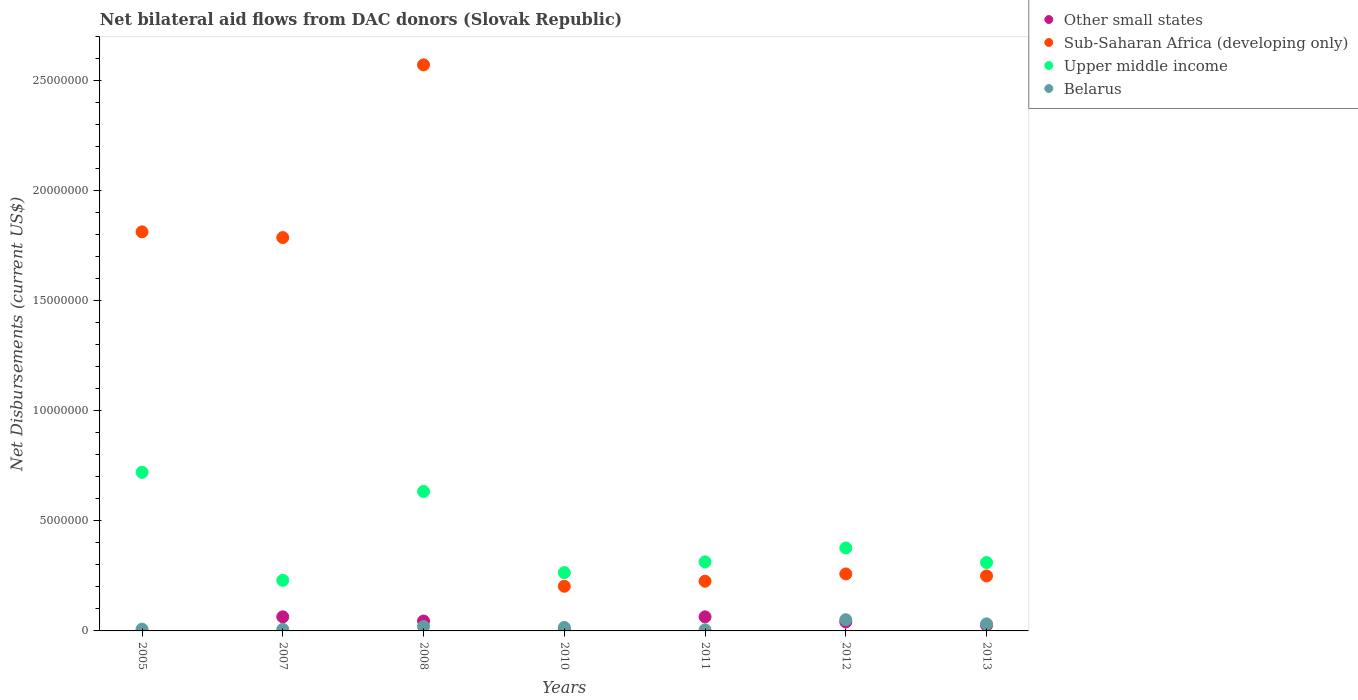What is the net bilateral aid flows in Upper middle income in 2011?
Keep it short and to the point. 3.14e+06. Across all years, what is the maximum net bilateral aid flows in Other small states?
Offer a terse response. 6.40e+05. In which year was the net bilateral aid flows in Upper middle income maximum?
Your answer should be very brief. 2005. What is the total net bilateral aid flows in Sub-Saharan Africa (developing only) in the graph?
Offer a terse response. 7.11e+07. What is the difference between the net bilateral aid flows in Upper middle income in 2011 and that in 2012?
Your answer should be compact. -6.30e+05. What is the difference between the net bilateral aid flows in Upper middle income in 2011 and the net bilateral aid flows in Belarus in 2007?
Keep it short and to the point. 3.07e+06. What is the average net bilateral aid flows in Upper middle income per year?
Provide a short and direct response. 4.07e+06. In the year 2012, what is the difference between the net bilateral aid flows in Sub-Saharan Africa (developing only) and net bilateral aid flows in Belarus?
Offer a terse response. 2.08e+06. In how many years, is the net bilateral aid flows in Belarus greater than 6000000 US$?
Your response must be concise. 0. What is the ratio of the net bilateral aid flows in Belarus in 2010 to that in 2013?
Your answer should be compact. 0.5. Is the net bilateral aid flows in Sub-Saharan Africa (developing only) in 2005 less than that in 2013?
Keep it short and to the point. No. What is the difference between the highest and the second highest net bilateral aid flows in Upper middle income?
Your response must be concise. 8.70e+05. What is the difference between the highest and the lowest net bilateral aid flows in Upper middle income?
Give a very brief answer. 4.91e+06. Is it the case that in every year, the sum of the net bilateral aid flows in Sub-Saharan Africa (developing only) and net bilateral aid flows in Upper middle income  is greater than the sum of net bilateral aid flows in Belarus and net bilateral aid flows in Other small states?
Provide a succinct answer. Yes. Is it the case that in every year, the sum of the net bilateral aid flows in Other small states and net bilateral aid flows in Sub-Saharan Africa (developing only)  is greater than the net bilateral aid flows in Belarus?
Your answer should be very brief. Yes. Does the net bilateral aid flows in Belarus monotonically increase over the years?
Keep it short and to the point. No. How many years are there in the graph?
Keep it short and to the point. 7. Are the values on the major ticks of Y-axis written in scientific E-notation?
Your answer should be very brief. No. Where does the legend appear in the graph?
Provide a short and direct response. Top right. How are the legend labels stacked?
Ensure brevity in your answer.  Vertical. What is the title of the graph?
Offer a terse response. Net bilateral aid flows from DAC donors (Slovak Republic). What is the label or title of the X-axis?
Your answer should be compact. Years. What is the label or title of the Y-axis?
Offer a very short reply. Net Disbursements (current US$). What is the Net Disbursements (current US$) in Sub-Saharan Africa (developing only) in 2005?
Give a very brief answer. 1.81e+07. What is the Net Disbursements (current US$) in Upper middle income in 2005?
Give a very brief answer. 7.21e+06. What is the Net Disbursements (current US$) in Belarus in 2005?
Provide a succinct answer. 8.00e+04. What is the Net Disbursements (current US$) in Other small states in 2007?
Offer a very short reply. 6.40e+05. What is the Net Disbursements (current US$) of Sub-Saharan Africa (developing only) in 2007?
Provide a succinct answer. 1.79e+07. What is the Net Disbursements (current US$) of Upper middle income in 2007?
Offer a terse response. 2.30e+06. What is the Net Disbursements (current US$) in Sub-Saharan Africa (developing only) in 2008?
Make the answer very short. 2.57e+07. What is the Net Disbursements (current US$) in Upper middle income in 2008?
Offer a terse response. 6.34e+06. What is the Net Disbursements (current US$) in Other small states in 2010?
Your response must be concise. 8.00e+04. What is the Net Disbursements (current US$) of Sub-Saharan Africa (developing only) in 2010?
Your answer should be very brief. 2.03e+06. What is the Net Disbursements (current US$) in Upper middle income in 2010?
Ensure brevity in your answer.  2.65e+06. What is the Net Disbursements (current US$) of Other small states in 2011?
Your response must be concise. 6.40e+05. What is the Net Disbursements (current US$) in Sub-Saharan Africa (developing only) in 2011?
Provide a succinct answer. 2.26e+06. What is the Net Disbursements (current US$) in Upper middle income in 2011?
Your answer should be compact. 3.14e+06. What is the Net Disbursements (current US$) of Other small states in 2012?
Ensure brevity in your answer.  4.10e+05. What is the Net Disbursements (current US$) in Sub-Saharan Africa (developing only) in 2012?
Keep it short and to the point. 2.59e+06. What is the Net Disbursements (current US$) of Upper middle income in 2012?
Ensure brevity in your answer.  3.77e+06. What is the Net Disbursements (current US$) of Belarus in 2012?
Give a very brief answer. 5.10e+05. What is the Net Disbursements (current US$) of Other small states in 2013?
Your answer should be compact. 2.60e+05. What is the Net Disbursements (current US$) of Sub-Saharan Africa (developing only) in 2013?
Keep it short and to the point. 2.50e+06. What is the Net Disbursements (current US$) in Upper middle income in 2013?
Ensure brevity in your answer.  3.11e+06. What is the Net Disbursements (current US$) of Belarus in 2013?
Provide a succinct answer. 3.20e+05. Across all years, what is the maximum Net Disbursements (current US$) in Other small states?
Your answer should be compact. 6.40e+05. Across all years, what is the maximum Net Disbursements (current US$) in Sub-Saharan Africa (developing only)?
Your response must be concise. 2.57e+07. Across all years, what is the maximum Net Disbursements (current US$) in Upper middle income?
Your response must be concise. 7.21e+06. Across all years, what is the maximum Net Disbursements (current US$) of Belarus?
Offer a very short reply. 5.10e+05. Across all years, what is the minimum Net Disbursements (current US$) of Sub-Saharan Africa (developing only)?
Keep it short and to the point. 2.03e+06. Across all years, what is the minimum Net Disbursements (current US$) of Upper middle income?
Offer a very short reply. 2.30e+06. What is the total Net Disbursements (current US$) of Other small states in the graph?
Your response must be concise. 2.49e+06. What is the total Net Disbursements (current US$) of Sub-Saharan Africa (developing only) in the graph?
Offer a very short reply. 7.11e+07. What is the total Net Disbursements (current US$) of Upper middle income in the graph?
Your answer should be very brief. 2.85e+07. What is the total Net Disbursements (current US$) of Belarus in the graph?
Your answer should be compact. 1.39e+06. What is the difference between the Net Disbursements (current US$) in Other small states in 2005 and that in 2007?
Offer a terse response. -6.30e+05. What is the difference between the Net Disbursements (current US$) of Upper middle income in 2005 and that in 2007?
Provide a succinct answer. 4.91e+06. What is the difference between the Net Disbursements (current US$) in Other small states in 2005 and that in 2008?
Offer a terse response. -4.40e+05. What is the difference between the Net Disbursements (current US$) in Sub-Saharan Africa (developing only) in 2005 and that in 2008?
Your answer should be very brief. -7.59e+06. What is the difference between the Net Disbursements (current US$) of Upper middle income in 2005 and that in 2008?
Your response must be concise. 8.70e+05. What is the difference between the Net Disbursements (current US$) of Belarus in 2005 and that in 2008?
Your answer should be very brief. -1.20e+05. What is the difference between the Net Disbursements (current US$) in Sub-Saharan Africa (developing only) in 2005 and that in 2010?
Provide a succinct answer. 1.61e+07. What is the difference between the Net Disbursements (current US$) of Upper middle income in 2005 and that in 2010?
Provide a short and direct response. 4.56e+06. What is the difference between the Net Disbursements (current US$) in Belarus in 2005 and that in 2010?
Your response must be concise. -8.00e+04. What is the difference between the Net Disbursements (current US$) of Other small states in 2005 and that in 2011?
Ensure brevity in your answer.  -6.30e+05. What is the difference between the Net Disbursements (current US$) of Sub-Saharan Africa (developing only) in 2005 and that in 2011?
Provide a short and direct response. 1.59e+07. What is the difference between the Net Disbursements (current US$) in Upper middle income in 2005 and that in 2011?
Your answer should be very brief. 4.07e+06. What is the difference between the Net Disbursements (current US$) of Other small states in 2005 and that in 2012?
Your answer should be very brief. -4.00e+05. What is the difference between the Net Disbursements (current US$) of Sub-Saharan Africa (developing only) in 2005 and that in 2012?
Give a very brief answer. 1.56e+07. What is the difference between the Net Disbursements (current US$) of Upper middle income in 2005 and that in 2012?
Provide a succinct answer. 3.44e+06. What is the difference between the Net Disbursements (current US$) of Belarus in 2005 and that in 2012?
Provide a succinct answer. -4.30e+05. What is the difference between the Net Disbursements (current US$) of Sub-Saharan Africa (developing only) in 2005 and that in 2013?
Your answer should be very brief. 1.56e+07. What is the difference between the Net Disbursements (current US$) in Upper middle income in 2005 and that in 2013?
Offer a very short reply. 4.10e+06. What is the difference between the Net Disbursements (current US$) in Sub-Saharan Africa (developing only) in 2007 and that in 2008?
Your answer should be compact. -7.85e+06. What is the difference between the Net Disbursements (current US$) in Upper middle income in 2007 and that in 2008?
Provide a succinct answer. -4.04e+06. What is the difference between the Net Disbursements (current US$) in Belarus in 2007 and that in 2008?
Give a very brief answer. -1.30e+05. What is the difference between the Net Disbursements (current US$) of Other small states in 2007 and that in 2010?
Your answer should be compact. 5.60e+05. What is the difference between the Net Disbursements (current US$) in Sub-Saharan Africa (developing only) in 2007 and that in 2010?
Give a very brief answer. 1.58e+07. What is the difference between the Net Disbursements (current US$) of Upper middle income in 2007 and that in 2010?
Ensure brevity in your answer.  -3.50e+05. What is the difference between the Net Disbursements (current US$) in Belarus in 2007 and that in 2010?
Offer a very short reply. -9.00e+04. What is the difference between the Net Disbursements (current US$) of Other small states in 2007 and that in 2011?
Provide a succinct answer. 0. What is the difference between the Net Disbursements (current US$) of Sub-Saharan Africa (developing only) in 2007 and that in 2011?
Offer a very short reply. 1.56e+07. What is the difference between the Net Disbursements (current US$) of Upper middle income in 2007 and that in 2011?
Provide a short and direct response. -8.40e+05. What is the difference between the Net Disbursements (current US$) of Other small states in 2007 and that in 2012?
Your response must be concise. 2.30e+05. What is the difference between the Net Disbursements (current US$) of Sub-Saharan Africa (developing only) in 2007 and that in 2012?
Offer a very short reply. 1.53e+07. What is the difference between the Net Disbursements (current US$) of Upper middle income in 2007 and that in 2012?
Ensure brevity in your answer.  -1.47e+06. What is the difference between the Net Disbursements (current US$) in Belarus in 2007 and that in 2012?
Give a very brief answer. -4.40e+05. What is the difference between the Net Disbursements (current US$) in Sub-Saharan Africa (developing only) in 2007 and that in 2013?
Your answer should be very brief. 1.54e+07. What is the difference between the Net Disbursements (current US$) of Upper middle income in 2007 and that in 2013?
Your answer should be very brief. -8.10e+05. What is the difference between the Net Disbursements (current US$) in Belarus in 2007 and that in 2013?
Provide a succinct answer. -2.50e+05. What is the difference between the Net Disbursements (current US$) in Sub-Saharan Africa (developing only) in 2008 and that in 2010?
Your response must be concise. 2.37e+07. What is the difference between the Net Disbursements (current US$) in Upper middle income in 2008 and that in 2010?
Give a very brief answer. 3.69e+06. What is the difference between the Net Disbursements (current US$) of Belarus in 2008 and that in 2010?
Offer a very short reply. 4.00e+04. What is the difference between the Net Disbursements (current US$) in Sub-Saharan Africa (developing only) in 2008 and that in 2011?
Provide a short and direct response. 2.35e+07. What is the difference between the Net Disbursements (current US$) in Upper middle income in 2008 and that in 2011?
Ensure brevity in your answer.  3.20e+06. What is the difference between the Net Disbursements (current US$) of Belarus in 2008 and that in 2011?
Your answer should be very brief. 1.50e+05. What is the difference between the Net Disbursements (current US$) in Other small states in 2008 and that in 2012?
Give a very brief answer. 4.00e+04. What is the difference between the Net Disbursements (current US$) in Sub-Saharan Africa (developing only) in 2008 and that in 2012?
Offer a terse response. 2.31e+07. What is the difference between the Net Disbursements (current US$) of Upper middle income in 2008 and that in 2012?
Make the answer very short. 2.57e+06. What is the difference between the Net Disbursements (current US$) of Belarus in 2008 and that in 2012?
Your answer should be very brief. -3.10e+05. What is the difference between the Net Disbursements (current US$) of Sub-Saharan Africa (developing only) in 2008 and that in 2013?
Keep it short and to the point. 2.32e+07. What is the difference between the Net Disbursements (current US$) in Upper middle income in 2008 and that in 2013?
Keep it short and to the point. 3.23e+06. What is the difference between the Net Disbursements (current US$) of Belarus in 2008 and that in 2013?
Provide a succinct answer. -1.20e+05. What is the difference between the Net Disbursements (current US$) of Other small states in 2010 and that in 2011?
Provide a short and direct response. -5.60e+05. What is the difference between the Net Disbursements (current US$) of Upper middle income in 2010 and that in 2011?
Provide a succinct answer. -4.90e+05. What is the difference between the Net Disbursements (current US$) of Belarus in 2010 and that in 2011?
Provide a short and direct response. 1.10e+05. What is the difference between the Net Disbursements (current US$) of Other small states in 2010 and that in 2012?
Your response must be concise. -3.30e+05. What is the difference between the Net Disbursements (current US$) of Sub-Saharan Africa (developing only) in 2010 and that in 2012?
Ensure brevity in your answer.  -5.60e+05. What is the difference between the Net Disbursements (current US$) in Upper middle income in 2010 and that in 2012?
Your answer should be very brief. -1.12e+06. What is the difference between the Net Disbursements (current US$) in Belarus in 2010 and that in 2012?
Ensure brevity in your answer.  -3.50e+05. What is the difference between the Net Disbursements (current US$) in Sub-Saharan Africa (developing only) in 2010 and that in 2013?
Your answer should be compact. -4.70e+05. What is the difference between the Net Disbursements (current US$) in Upper middle income in 2010 and that in 2013?
Keep it short and to the point. -4.60e+05. What is the difference between the Net Disbursements (current US$) in Belarus in 2010 and that in 2013?
Make the answer very short. -1.60e+05. What is the difference between the Net Disbursements (current US$) in Other small states in 2011 and that in 2012?
Provide a succinct answer. 2.30e+05. What is the difference between the Net Disbursements (current US$) in Sub-Saharan Africa (developing only) in 2011 and that in 2012?
Ensure brevity in your answer.  -3.30e+05. What is the difference between the Net Disbursements (current US$) of Upper middle income in 2011 and that in 2012?
Provide a succinct answer. -6.30e+05. What is the difference between the Net Disbursements (current US$) in Belarus in 2011 and that in 2012?
Your response must be concise. -4.60e+05. What is the difference between the Net Disbursements (current US$) of Sub-Saharan Africa (developing only) in 2011 and that in 2013?
Provide a succinct answer. -2.40e+05. What is the difference between the Net Disbursements (current US$) in Belarus in 2011 and that in 2013?
Offer a very short reply. -2.70e+05. What is the difference between the Net Disbursements (current US$) in Other small states in 2012 and that in 2013?
Keep it short and to the point. 1.50e+05. What is the difference between the Net Disbursements (current US$) of Other small states in 2005 and the Net Disbursements (current US$) of Sub-Saharan Africa (developing only) in 2007?
Your answer should be compact. -1.79e+07. What is the difference between the Net Disbursements (current US$) of Other small states in 2005 and the Net Disbursements (current US$) of Upper middle income in 2007?
Your answer should be very brief. -2.29e+06. What is the difference between the Net Disbursements (current US$) of Sub-Saharan Africa (developing only) in 2005 and the Net Disbursements (current US$) of Upper middle income in 2007?
Keep it short and to the point. 1.58e+07. What is the difference between the Net Disbursements (current US$) of Sub-Saharan Africa (developing only) in 2005 and the Net Disbursements (current US$) of Belarus in 2007?
Your answer should be very brief. 1.81e+07. What is the difference between the Net Disbursements (current US$) of Upper middle income in 2005 and the Net Disbursements (current US$) of Belarus in 2007?
Make the answer very short. 7.14e+06. What is the difference between the Net Disbursements (current US$) of Other small states in 2005 and the Net Disbursements (current US$) of Sub-Saharan Africa (developing only) in 2008?
Provide a succinct answer. -2.57e+07. What is the difference between the Net Disbursements (current US$) of Other small states in 2005 and the Net Disbursements (current US$) of Upper middle income in 2008?
Offer a very short reply. -6.33e+06. What is the difference between the Net Disbursements (current US$) in Other small states in 2005 and the Net Disbursements (current US$) in Belarus in 2008?
Give a very brief answer. -1.90e+05. What is the difference between the Net Disbursements (current US$) of Sub-Saharan Africa (developing only) in 2005 and the Net Disbursements (current US$) of Upper middle income in 2008?
Give a very brief answer. 1.18e+07. What is the difference between the Net Disbursements (current US$) in Sub-Saharan Africa (developing only) in 2005 and the Net Disbursements (current US$) in Belarus in 2008?
Keep it short and to the point. 1.79e+07. What is the difference between the Net Disbursements (current US$) of Upper middle income in 2005 and the Net Disbursements (current US$) of Belarus in 2008?
Give a very brief answer. 7.01e+06. What is the difference between the Net Disbursements (current US$) of Other small states in 2005 and the Net Disbursements (current US$) of Sub-Saharan Africa (developing only) in 2010?
Your response must be concise. -2.02e+06. What is the difference between the Net Disbursements (current US$) in Other small states in 2005 and the Net Disbursements (current US$) in Upper middle income in 2010?
Offer a terse response. -2.64e+06. What is the difference between the Net Disbursements (current US$) in Other small states in 2005 and the Net Disbursements (current US$) in Belarus in 2010?
Offer a very short reply. -1.50e+05. What is the difference between the Net Disbursements (current US$) in Sub-Saharan Africa (developing only) in 2005 and the Net Disbursements (current US$) in Upper middle income in 2010?
Keep it short and to the point. 1.55e+07. What is the difference between the Net Disbursements (current US$) of Sub-Saharan Africa (developing only) in 2005 and the Net Disbursements (current US$) of Belarus in 2010?
Provide a succinct answer. 1.80e+07. What is the difference between the Net Disbursements (current US$) of Upper middle income in 2005 and the Net Disbursements (current US$) of Belarus in 2010?
Keep it short and to the point. 7.05e+06. What is the difference between the Net Disbursements (current US$) of Other small states in 2005 and the Net Disbursements (current US$) of Sub-Saharan Africa (developing only) in 2011?
Your answer should be very brief. -2.25e+06. What is the difference between the Net Disbursements (current US$) of Other small states in 2005 and the Net Disbursements (current US$) of Upper middle income in 2011?
Your answer should be compact. -3.13e+06. What is the difference between the Net Disbursements (current US$) in Sub-Saharan Africa (developing only) in 2005 and the Net Disbursements (current US$) in Upper middle income in 2011?
Your answer should be compact. 1.50e+07. What is the difference between the Net Disbursements (current US$) in Sub-Saharan Africa (developing only) in 2005 and the Net Disbursements (current US$) in Belarus in 2011?
Provide a short and direct response. 1.81e+07. What is the difference between the Net Disbursements (current US$) in Upper middle income in 2005 and the Net Disbursements (current US$) in Belarus in 2011?
Your answer should be compact. 7.16e+06. What is the difference between the Net Disbursements (current US$) of Other small states in 2005 and the Net Disbursements (current US$) of Sub-Saharan Africa (developing only) in 2012?
Offer a terse response. -2.58e+06. What is the difference between the Net Disbursements (current US$) in Other small states in 2005 and the Net Disbursements (current US$) in Upper middle income in 2012?
Provide a short and direct response. -3.76e+06. What is the difference between the Net Disbursements (current US$) of Other small states in 2005 and the Net Disbursements (current US$) of Belarus in 2012?
Your answer should be compact. -5.00e+05. What is the difference between the Net Disbursements (current US$) in Sub-Saharan Africa (developing only) in 2005 and the Net Disbursements (current US$) in Upper middle income in 2012?
Your response must be concise. 1.44e+07. What is the difference between the Net Disbursements (current US$) in Sub-Saharan Africa (developing only) in 2005 and the Net Disbursements (current US$) in Belarus in 2012?
Make the answer very short. 1.76e+07. What is the difference between the Net Disbursements (current US$) of Upper middle income in 2005 and the Net Disbursements (current US$) of Belarus in 2012?
Make the answer very short. 6.70e+06. What is the difference between the Net Disbursements (current US$) in Other small states in 2005 and the Net Disbursements (current US$) in Sub-Saharan Africa (developing only) in 2013?
Provide a succinct answer. -2.49e+06. What is the difference between the Net Disbursements (current US$) in Other small states in 2005 and the Net Disbursements (current US$) in Upper middle income in 2013?
Your answer should be compact. -3.10e+06. What is the difference between the Net Disbursements (current US$) of Other small states in 2005 and the Net Disbursements (current US$) of Belarus in 2013?
Ensure brevity in your answer.  -3.10e+05. What is the difference between the Net Disbursements (current US$) of Sub-Saharan Africa (developing only) in 2005 and the Net Disbursements (current US$) of Upper middle income in 2013?
Offer a very short reply. 1.50e+07. What is the difference between the Net Disbursements (current US$) in Sub-Saharan Africa (developing only) in 2005 and the Net Disbursements (current US$) in Belarus in 2013?
Ensure brevity in your answer.  1.78e+07. What is the difference between the Net Disbursements (current US$) in Upper middle income in 2005 and the Net Disbursements (current US$) in Belarus in 2013?
Provide a short and direct response. 6.89e+06. What is the difference between the Net Disbursements (current US$) of Other small states in 2007 and the Net Disbursements (current US$) of Sub-Saharan Africa (developing only) in 2008?
Provide a succinct answer. -2.51e+07. What is the difference between the Net Disbursements (current US$) in Other small states in 2007 and the Net Disbursements (current US$) in Upper middle income in 2008?
Offer a terse response. -5.70e+06. What is the difference between the Net Disbursements (current US$) of Sub-Saharan Africa (developing only) in 2007 and the Net Disbursements (current US$) of Upper middle income in 2008?
Your answer should be very brief. 1.15e+07. What is the difference between the Net Disbursements (current US$) in Sub-Saharan Africa (developing only) in 2007 and the Net Disbursements (current US$) in Belarus in 2008?
Your answer should be very brief. 1.77e+07. What is the difference between the Net Disbursements (current US$) in Upper middle income in 2007 and the Net Disbursements (current US$) in Belarus in 2008?
Ensure brevity in your answer.  2.10e+06. What is the difference between the Net Disbursements (current US$) of Other small states in 2007 and the Net Disbursements (current US$) of Sub-Saharan Africa (developing only) in 2010?
Provide a succinct answer. -1.39e+06. What is the difference between the Net Disbursements (current US$) in Other small states in 2007 and the Net Disbursements (current US$) in Upper middle income in 2010?
Make the answer very short. -2.01e+06. What is the difference between the Net Disbursements (current US$) in Other small states in 2007 and the Net Disbursements (current US$) in Belarus in 2010?
Offer a very short reply. 4.80e+05. What is the difference between the Net Disbursements (current US$) of Sub-Saharan Africa (developing only) in 2007 and the Net Disbursements (current US$) of Upper middle income in 2010?
Give a very brief answer. 1.52e+07. What is the difference between the Net Disbursements (current US$) in Sub-Saharan Africa (developing only) in 2007 and the Net Disbursements (current US$) in Belarus in 2010?
Ensure brevity in your answer.  1.77e+07. What is the difference between the Net Disbursements (current US$) in Upper middle income in 2007 and the Net Disbursements (current US$) in Belarus in 2010?
Provide a short and direct response. 2.14e+06. What is the difference between the Net Disbursements (current US$) in Other small states in 2007 and the Net Disbursements (current US$) in Sub-Saharan Africa (developing only) in 2011?
Offer a very short reply. -1.62e+06. What is the difference between the Net Disbursements (current US$) in Other small states in 2007 and the Net Disbursements (current US$) in Upper middle income in 2011?
Give a very brief answer. -2.50e+06. What is the difference between the Net Disbursements (current US$) in Other small states in 2007 and the Net Disbursements (current US$) in Belarus in 2011?
Make the answer very short. 5.90e+05. What is the difference between the Net Disbursements (current US$) of Sub-Saharan Africa (developing only) in 2007 and the Net Disbursements (current US$) of Upper middle income in 2011?
Make the answer very short. 1.47e+07. What is the difference between the Net Disbursements (current US$) of Sub-Saharan Africa (developing only) in 2007 and the Net Disbursements (current US$) of Belarus in 2011?
Provide a succinct answer. 1.78e+07. What is the difference between the Net Disbursements (current US$) in Upper middle income in 2007 and the Net Disbursements (current US$) in Belarus in 2011?
Keep it short and to the point. 2.25e+06. What is the difference between the Net Disbursements (current US$) in Other small states in 2007 and the Net Disbursements (current US$) in Sub-Saharan Africa (developing only) in 2012?
Your answer should be very brief. -1.95e+06. What is the difference between the Net Disbursements (current US$) in Other small states in 2007 and the Net Disbursements (current US$) in Upper middle income in 2012?
Keep it short and to the point. -3.13e+06. What is the difference between the Net Disbursements (current US$) in Other small states in 2007 and the Net Disbursements (current US$) in Belarus in 2012?
Offer a terse response. 1.30e+05. What is the difference between the Net Disbursements (current US$) in Sub-Saharan Africa (developing only) in 2007 and the Net Disbursements (current US$) in Upper middle income in 2012?
Make the answer very short. 1.41e+07. What is the difference between the Net Disbursements (current US$) in Sub-Saharan Africa (developing only) in 2007 and the Net Disbursements (current US$) in Belarus in 2012?
Offer a terse response. 1.74e+07. What is the difference between the Net Disbursements (current US$) in Upper middle income in 2007 and the Net Disbursements (current US$) in Belarus in 2012?
Your answer should be very brief. 1.79e+06. What is the difference between the Net Disbursements (current US$) in Other small states in 2007 and the Net Disbursements (current US$) in Sub-Saharan Africa (developing only) in 2013?
Your answer should be very brief. -1.86e+06. What is the difference between the Net Disbursements (current US$) in Other small states in 2007 and the Net Disbursements (current US$) in Upper middle income in 2013?
Make the answer very short. -2.47e+06. What is the difference between the Net Disbursements (current US$) in Other small states in 2007 and the Net Disbursements (current US$) in Belarus in 2013?
Offer a very short reply. 3.20e+05. What is the difference between the Net Disbursements (current US$) of Sub-Saharan Africa (developing only) in 2007 and the Net Disbursements (current US$) of Upper middle income in 2013?
Keep it short and to the point. 1.48e+07. What is the difference between the Net Disbursements (current US$) of Sub-Saharan Africa (developing only) in 2007 and the Net Disbursements (current US$) of Belarus in 2013?
Your answer should be very brief. 1.76e+07. What is the difference between the Net Disbursements (current US$) of Upper middle income in 2007 and the Net Disbursements (current US$) of Belarus in 2013?
Keep it short and to the point. 1.98e+06. What is the difference between the Net Disbursements (current US$) in Other small states in 2008 and the Net Disbursements (current US$) in Sub-Saharan Africa (developing only) in 2010?
Your answer should be compact. -1.58e+06. What is the difference between the Net Disbursements (current US$) in Other small states in 2008 and the Net Disbursements (current US$) in Upper middle income in 2010?
Offer a terse response. -2.20e+06. What is the difference between the Net Disbursements (current US$) in Sub-Saharan Africa (developing only) in 2008 and the Net Disbursements (current US$) in Upper middle income in 2010?
Offer a terse response. 2.31e+07. What is the difference between the Net Disbursements (current US$) of Sub-Saharan Africa (developing only) in 2008 and the Net Disbursements (current US$) of Belarus in 2010?
Give a very brief answer. 2.56e+07. What is the difference between the Net Disbursements (current US$) in Upper middle income in 2008 and the Net Disbursements (current US$) in Belarus in 2010?
Give a very brief answer. 6.18e+06. What is the difference between the Net Disbursements (current US$) of Other small states in 2008 and the Net Disbursements (current US$) of Sub-Saharan Africa (developing only) in 2011?
Offer a very short reply. -1.81e+06. What is the difference between the Net Disbursements (current US$) in Other small states in 2008 and the Net Disbursements (current US$) in Upper middle income in 2011?
Ensure brevity in your answer.  -2.69e+06. What is the difference between the Net Disbursements (current US$) in Sub-Saharan Africa (developing only) in 2008 and the Net Disbursements (current US$) in Upper middle income in 2011?
Your answer should be compact. 2.26e+07. What is the difference between the Net Disbursements (current US$) in Sub-Saharan Africa (developing only) in 2008 and the Net Disbursements (current US$) in Belarus in 2011?
Offer a terse response. 2.57e+07. What is the difference between the Net Disbursements (current US$) of Upper middle income in 2008 and the Net Disbursements (current US$) of Belarus in 2011?
Your answer should be compact. 6.29e+06. What is the difference between the Net Disbursements (current US$) in Other small states in 2008 and the Net Disbursements (current US$) in Sub-Saharan Africa (developing only) in 2012?
Offer a terse response. -2.14e+06. What is the difference between the Net Disbursements (current US$) in Other small states in 2008 and the Net Disbursements (current US$) in Upper middle income in 2012?
Make the answer very short. -3.32e+06. What is the difference between the Net Disbursements (current US$) in Sub-Saharan Africa (developing only) in 2008 and the Net Disbursements (current US$) in Upper middle income in 2012?
Keep it short and to the point. 2.20e+07. What is the difference between the Net Disbursements (current US$) in Sub-Saharan Africa (developing only) in 2008 and the Net Disbursements (current US$) in Belarus in 2012?
Your answer should be very brief. 2.52e+07. What is the difference between the Net Disbursements (current US$) in Upper middle income in 2008 and the Net Disbursements (current US$) in Belarus in 2012?
Offer a very short reply. 5.83e+06. What is the difference between the Net Disbursements (current US$) in Other small states in 2008 and the Net Disbursements (current US$) in Sub-Saharan Africa (developing only) in 2013?
Offer a very short reply. -2.05e+06. What is the difference between the Net Disbursements (current US$) of Other small states in 2008 and the Net Disbursements (current US$) of Upper middle income in 2013?
Your answer should be very brief. -2.66e+06. What is the difference between the Net Disbursements (current US$) of Sub-Saharan Africa (developing only) in 2008 and the Net Disbursements (current US$) of Upper middle income in 2013?
Provide a succinct answer. 2.26e+07. What is the difference between the Net Disbursements (current US$) of Sub-Saharan Africa (developing only) in 2008 and the Net Disbursements (current US$) of Belarus in 2013?
Your response must be concise. 2.54e+07. What is the difference between the Net Disbursements (current US$) of Upper middle income in 2008 and the Net Disbursements (current US$) of Belarus in 2013?
Your response must be concise. 6.02e+06. What is the difference between the Net Disbursements (current US$) in Other small states in 2010 and the Net Disbursements (current US$) in Sub-Saharan Africa (developing only) in 2011?
Your response must be concise. -2.18e+06. What is the difference between the Net Disbursements (current US$) of Other small states in 2010 and the Net Disbursements (current US$) of Upper middle income in 2011?
Your answer should be very brief. -3.06e+06. What is the difference between the Net Disbursements (current US$) of Sub-Saharan Africa (developing only) in 2010 and the Net Disbursements (current US$) of Upper middle income in 2011?
Provide a short and direct response. -1.11e+06. What is the difference between the Net Disbursements (current US$) in Sub-Saharan Africa (developing only) in 2010 and the Net Disbursements (current US$) in Belarus in 2011?
Ensure brevity in your answer.  1.98e+06. What is the difference between the Net Disbursements (current US$) of Upper middle income in 2010 and the Net Disbursements (current US$) of Belarus in 2011?
Give a very brief answer. 2.60e+06. What is the difference between the Net Disbursements (current US$) of Other small states in 2010 and the Net Disbursements (current US$) of Sub-Saharan Africa (developing only) in 2012?
Give a very brief answer. -2.51e+06. What is the difference between the Net Disbursements (current US$) in Other small states in 2010 and the Net Disbursements (current US$) in Upper middle income in 2012?
Offer a terse response. -3.69e+06. What is the difference between the Net Disbursements (current US$) in Other small states in 2010 and the Net Disbursements (current US$) in Belarus in 2012?
Make the answer very short. -4.30e+05. What is the difference between the Net Disbursements (current US$) in Sub-Saharan Africa (developing only) in 2010 and the Net Disbursements (current US$) in Upper middle income in 2012?
Provide a succinct answer. -1.74e+06. What is the difference between the Net Disbursements (current US$) of Sub-Saharan Africa (developing only) in 2010 and the Net Disbursements (current US$) of Belarus in 2012?
Offer a very short reply. 1.52e+06. What is the difference between the Net Disbursements (current US$) of Upper middle income in 2010 and the Net Disbursements (current US$) of Belarus in 2012?
Your answer should be compact. 2.14e+06. What is the difference between the Net Disbursements (current US$) in Other small states in 2010 and the Net Disbursements (current US$) in Sub-Saharan Africa (developing only) in 2013?
Give a very brief answer. -2.42e+06. What is the difference between the Net Disbursements (current US$) of Other small states in 2010 and the Net Disbursements (current US$) of Upper middle income in 2013?
Make the answer very short. -3.03e+06. What is the difference between the Net Disbursements (current US$) of Sub-Saharan Africa (developing only) in 2010 and the Net Disbursements (current US$) of Upper middle income in 2013?
Your answer should be very brief. -1.08e+06. What is the difference between the Net Disbursements (current US$) in Sub-Saharan Africa (developing only) in 2010 and the Net Disbursements (current US$) in Belarus in 2013?
Offer a terse response. 1.71e+06. What is the difference between the Net Disbursements (current US$) in Upper middle income in 2010 and the Net Disbursements (current US$) in Belarus in 2013?
Provide a short and direct response. 2.33e+06. What is the difference between the Net Disbursements (current US$) in Other small states in 2011 and the Net Disbursements (current US$) in Sub-Saharan Africa (developing only) in 2012?
Offer a very short reply. -1.95e+06. What is the difference between the Net Disbursements (current US$) of Other small states in 2011 and the Net Disbursements (current US$) of Upper middle income in 2012?
Offer a terse response. -3.13e+06. What is the difference between the Net Disbursements (current US$) of Sub-Saharan Africa (developing only) in 2011 and the Net Disbursements (current US$) of Upper middle income in 2012?
Offer a very short reply. -1.51e+06. What is the difference between the Net Disbursements (current US$) in Sub-Saharan Africa (developing only) in 2011 and the Net Disbursements (current US$) in Belarus in 2012?
Your answer should be compact. 1.75e+06. What is the difference between the Net Disbursements (current US$) of Upper middle income in 2011 and the Net Disbursements (current US$) of Belarus in 2012?
Make the answer very short. 2.63e+06. What is the difference between the Net Disbursements (current US$) of Other small states in 2011 and the Net Disbursements (current US$) of Sub-Saharan Africa (developing only) in 2013?
Your answer should be very brief. -1.86e+06. What is the difference between the Net Disbursements (current US$) of Other small states in 2011 and the Net Disbursements (current US$) of Upper middle income in 2013?
Make the answer very short. -2.47e+06. What is the difference between the Net Disbursements (current US$) in Sub-Saharan Africa (developing only) in 2011 and the Net Disbursements (current US$) in Upper middle income in 2013?
Provide a succinct answer. -8.50e+05. What is the difference between the Net Disbursements (current US$) in Sub-Saharan Africa (developing only) in 2011 and the Net Disbursements (current US$) in Belarus in 2013?
Provide a short and direct response. 1.94e+06. What is the difference between the Net Disbursements (current US$) of Upper middle income in 2011 and the Net Disbursements (current US$) of Belarus in 2013?
Offer a very short reply. 2.82e+06. What is the difference between the Net Disbursements (current US$) in Other small states in 2012 and the Net Disbursements (current US$) in Sub-Saharan Africa (developing only) in 2013?
Your answer should be compact. -2.09e+06. What is the difference between the Net Disbursements (current US$) of Other small states in 2012 and the Net Disbursements (current US$) of Upper middle income in 2013?
Your response must be concise. -2.70e+06. What is the difference between the Net Disbursements (current US$) of Other small states in 2012 and the Net Disbursements (current US$) of Belarus in 2013?
Ensure brevity in your answer.  9.00e+04. What is the difference between the Net Disbursements (current US$) of Sub-Saharan Africa (developing only) in 2012 and the Net Disbursements (current US$) of Upper middle income in 2013?
Offer a very short reply. -5.20e+05. What is the difference between the Net Disbursements (current US$) of Sub-Saharan Africa (developing only) in 2012 and the Net Disbursements (current US$) of Belarus in 2013?
Ensure brevity in your answer.  2.27e+06. What is the difference between the Net Disbursements (current US$) in Upper middle income in 2012 and the Net Disbursements (current US$) in Belarus in 2013?
Your answer should be very brief. 3.45e+06. What is the average Net Disbursements (current US$) of Other small states per year?
Provide a short and direct response. 3.56e+05. What is the average Net Disbursements (current US$) of Sub-Saharan Africa (developing only) per year?
Offer a terse response. 1.02e+07. What is the average Net Disbursements (current US$) of Upper middle income per year?
Provide a short and direct response. 4.07e+06. What is the average Net Disbursements (current US$) in Belarus per year?
Provide a short and direct response. 1.99e+05. In the year 2005, what is the difference between the Net Disbursements (current US$) of Other small states and Net Disbursements (current US$) of Sub-Saharan Africa (developing only)?
Offer a terse response. -1.81e+07. In the year 2005, what is the difference between the Net Disbursements (current US$) of Other small states and Net Disbursements (current US$) of Upper middle income?
Offer a very short reply. -7.20e+06. In the year 2005, what is the difference between the Net Disbursements (current US$) of Sub-Saharan Africa (developing only) and Net Disbursements (current US$) of Upper middle income?
Offer a terse response. 1.09e+07. In the year 2005, what is the difference between the Net Disbursements (current US$) of Sub-Saharan Africa (developing only) and Net Disbursements (current US$) of Belarus?
Your answer should be very brief. 1.81e+07. In the year 2005, what is the difference between the Net Disbursements (current US$) in Upper middle income and Net Disbursements (current US$) in Belarus?
Your response must be concise. 7.13e+06. In the year 2007, what is the difference between the Net Disbursements (current US$) of Other small states and Net Disbursements (current US$) of Sub-Saharan Africa (developing only)?
Give a very brief answer. -1.72e+07. In the year 2007, what is the difference between the Net Disbursements (current US$) in Other small states and Net Disbursements (current US$) in Upper middle income?
Provide a succinct answer. -1.66e+06. In the year 2007, what is the difference between the Net Disbursements (current US$) of Other small states and Net Disbursements (current US$) of Belarus?
Your response must be concise. 5.70e+05. In the year 2007, what is the difference between the Net Disbursements (current US$) in Sub-Saharan Africa (developing only) and Net Disbursements (current US$) in Upper middle income?
Keep it short and to the point. 1.56e+07. In the year 2007, what is the difference between the Net Disbursements (current US$) of Sub-Saharan Africa (developing only) and Net Disbursements (current US$) of Belarus?
Ensure brevity in your answer.  1.78e+07. In the year 2007, what is the difference between the Net Disbursements (current US$) in Upper middle income and Net Disbursements (current US$) in Belarus?
Your answer should be compact. 2.23e+06. In the year 2008, what is the difference between the Net Disbursements (current US$) in Other small states and Net Disbursements (current US$) in Sub-Saharan Africa (developing only)?
Your answer should be compact. -2.53e+07. In the year 2008, what is the difference between the Net Disbursements (current US$) of Other small states and Net Disbursements (current US$) of Upper middle income?
Offer a terse response. -5.89e+06. In the year 2008, what is the difference between the Net Disbursements (current US$) in Sub-Saharan Africa (developing only) and Net Disbursements (current US$) in Upper middle income?
Provide a succinct answer. 1.94e+07. In the year 2008, what is the difference between the Net Disbursements (current US$) of Sub-Saharan Africa (developing only) and Net Disbursements (current US$) of Belarus?
Provide a succinct answer. 2.55e+07. In the year 2008, what is the difference between the Net Disbursements (current US$) in Upper middle income and Net Disbursements (current US$) in Belarus?
Make the answer very short. 6.14e+06. In the year 2010, what is the difference between the Net Disbursements (current US$) of Other small states and Net Disbursements (current US$) of Sub-Saharan Africa (developing only)?
Ensure brevity in your answer.  -1.95e+06. In the year 2010, what is the difference between the Net Disbursements (current US$) in Other small states and Net Disbursements (current US$) in Upper middle income?
Give a very brief answer. -2.57e+06. In the year 2010, what is the difference between the Net Disbursements (current US$) in Sub-Saharan Africa (developing only) and Net Disbursements (current US$) in Upper middle income?
Give a very brief answer. -6.20e+05. In the year 2010, what is the difference between the Net Disbursements (current US$) of Sub-Saharan Africa (developing only) and Net Disbursements (current US$) of Belarus?
Provide a succinct answer. 1.87e+06. In the year 2010, what is the difference between the Net Disbursements (current US$) of Upper middle income and Net Disbursements (current US$) of Belarus?
Provide a succinct answer. 2.49e+06. In the year 2011, what is the difference between the Net Disbursements (current US$) of Other small states and Net Disbursements (current US$) of Sub-Saharan Africa (developing only)?
Give a very brief answer. -1.62e+06. In the year 2011, what is the difference between the Net Disbursements (current US$) in Other small states and Net Disbursements (current US$) in Upper middle income?
Your answer should be very brief. -2.50e+06. In the year 2011, what is the difference between the Net Disbursements (current US$) of Other small states and Net Disbursements (current US$) of Belarus?
Make the answer very short. 5.90e+05. In the year 2011, what is the difference between the Net Disbursements (current US$) in Sub-Saharan Africa (developing only) and Net Disbursements (current US$) in Upper middle income?
Your response must be concise. -8.80e+05. In the year 2011, what is the difference between the Net Disbursements (current US$) of Sub-Saharan Africa (developing only) and Net Disbursements (current US$) of Belarus?
Give a very brief answer. 2.21e+06. In the year 2011, what is the difference between the Net Disbursements (current US$) in Upper middle income and Net Disbursements (current US$) in Belarus?
Your response must be concise. 3.09e+06. In the year 2012, what is the difference between the Net Disbursements (current US$) of Other small states and Net Disbursements (current US$) of Sub-Saharan Africa (developing only)?
Provide a succinct answer. -2.18e+06. In the year 2012, what is the difference between the Net Disbursements (current US$) of Other small states and Net Disbursements (current US$) of Upper middle income?
Offer a terse response. -3.36e+06. In the year 2012, what is the difference between the Net Disbursements (current US$) in Sub-Saharan Africa (developing only) and Net Disbursements (current US$) in Upper middle income?
Offer a terse response. -1.18e+06. In the year 2012, what is the difference between the Net Disbursements (current US$) in Sub-Saharan Africa (developing only) and Net Disbursements (current US$) in Belarus?
Your response must be concise. 2.08e+06. In the year 2012, what is the difference between the Net Disbursements (current US$) in Upper middle income and Net Disbursements (current US$) in Belarus?
Give a very brief answer. 3.26e+06. In the year 2013, what is the difference between the Net Disbursements (current US$) in Other small states and Net Disbursements (current US$) in Sub-Saharan Africa (developing only)?
Ensure brevity in your answer.  -2.24e+06. In the year 2013, what is the difference between the Net Disbursements (current US$) of Other small states and Net Disbursements (current US$) of Upper middle income?
Offer a very short reply. -2.85e+06. In the year 2013, what is the difference between the Net Disbursements (current US$) of Sub-Saharan Africa (developing only) and Net Disbursements (current US$) of Upper middle income?
Your answer should be very brief. -6.10e+05. In the year 2013, what is the difference between the Net Disbursements (current US$) of Sub-Saharan Africa (developing only) and Net Disbursements (current US$) of Belarus?
Your answer should be very brief. 2.18e+06. In the year 2013, what is the difference between the Net Disbursements (current US$) in Upper middle income and Net Disbursements (current US$) in Belarus?
Offer a very short reply. 2.79e+06. What is the ratio of the Net Disbursements (current US$) in Other small states in 2005 to that in 2007?
Make the answer very short. 0.02. What is the ratio of the Net Disbursements (current US$) of Sub-Saharan Africa (developing only) in 2005 to that in 2007?
Offer a very short reply. 1.01. What is the ratio of the Net Disbursements (current US$) in Upper middle income in 2005 to that in 2007?
Offer a terse response. 3.13. What is the ratio of the Net Disbursements (current US$) in Other small states in 2005 to that in 2008?
Give a very brief answer. 0.02. What is the ratio of the Net Disbursements (current US$) of Sub-Saharan Africa (developing only) in 2005 to that in 2008?
Make the answer very short. 0.7. What is the ratio of the Net Disbursements (current US$) in Upper middle income in 2005 to that in 2008?
Provide a short and direct response. 1.14. What is the ratio of the Net Disbursements (current US$) of Belarus in 2005 to that in 2008?
Offer a very short reply. 0.4. What is the ratio of the Net Disbursements (current US$) of Sub-Saharan Africa (developing only) in 2005 to that in 2010?
Your response must be concise. 8.94. What is the ratio of the Net Disbursements (current US$) in Upper middle income in 2005 to that in 2010?
Offer a very short reply. 2.72. What is the ratio of the Net Disbursements (current US$) of Other small states in 2005 to that in 2011?
Give a very brief answer. 0.02. What is the ratio of the Net Disbursements (current US$) of Sub-Saharan Africa (developing only) in 2005 to that in 2011?
Offer a very short reply. 8.03. What is the ratio of the Net Disbursements (current US$) of Upper middle income in 2005 to that in 2011?
Your response must be concise. 2.3. What is the ratio of the Net Disbursements (current US$) of Belarus in 2005 to that in 2011?
Provide a short and direct response. 1.6. What is the ratio of the Net Disbursements (current US$) in Other small states in 2005 to that in 2012?
Provide a short and direct response. 0.02. What is the ratio of the Net Disbursements (current US$) in Sub-Saharan Africa (developing only) in 2005 to that in 2012?
Make the answer very short. 7. What is the ratio of the Net Disbursements (current US$) of Upper middle income in 2005 to that in 2012?
Keep it short and to the point. 1.91. What is the ratio of the Net Disbursements (current US$) of Belarus in 2005 to that in 2012?
Offer a terse response. 0.16. What is the ratio of the Net Disbursements (current US$) in Other small states in 2005 to that in 2013?
Keep it short and to the point. 0.04. What is the ratio of the Net Disbursements (current US$) of Sub-Saharan Africa (developing only) in 2005 to that in 2013?
Your response must be concise. 7.26. What is the ratio of the Net Disbursements (current US$) in Upper middle income in 2005 to that in 2013?
Offer a very short reply. 2.32. What is the ratio of the Net Disbursements (current US$) of Belarus in 2005 to that in 2013?
Your response must be concise. 0.25. What is the ratio of the Net Disbursements (current US$) in Other small states in 2007 to that in 2008?
Your answer should be very brief. 1.42. What is the ratio of the Net Disbursements (current US$) of Sub-Saharan Africa (developing only) in 2007 to that in 2008?
Make the answer very short. 0.69. What is the ratio of the Net Disbursements (current US$) of Upper middle income in 2007 to that in 2008?
Keep it short and to the point. 0.36. What is the ratio of the Net Disbursements (current US$) in Belarus in 2007 to that in 2008?
Your response must be concise. 0.35. What is the ratio of the Net Disbursements (current US$) in Other small states in 2007 to that in 2010?
Your answer should be compact. 8. What is the ratio of the Net Disbursements (current US$) in Sub-Saharan Africa (developing only) in 2007 to that in 2010?
Keep it short and to the point. 8.81. What is the ratio of the Net Disbursements (current US$) of Upper middle income in 2007 to that in 2010?
Your answer should be compact. 0.87. What is the ratio of the Net Disbursements (current US$) of Belarus in 2007 to that in 2010?
Keep it short and to the point. 0.44. What is the ratio of the Net Disbursements (current US$) of Other small states in 2007 to that in 2011?
Give a very brief answer. 1. What is the ratio of the Net Disbursements (current US$) of Sub-Saharan Africa (developing only) in 2007 to that in 2011?
Your answer should be very brief. 7.91. What is the ratio of the Net Disbursements (current US$) in Upper middle income in 2007 to that in 2011?
Provide a short and direct response. 0.73. What is the ratio of the Net Disbursements (current US$) in Belarus in 2007 to that in 2011?
Offer a very short reply. 1.4. What is the ratio of the Net Disbursements (current US$) of Other small states in 2007 to that in 2012?
Offer a very short reply. 1.56. What is the ratio of the Net Disbursements (current US$) of Sub-Saharan Africa (developing only) in 2007 to that in 2012?
Keep it short and to the point. 6.9. What is the ratio of the Net Disbursements (current US$) in Upper middle income in 2007 to that in 2012?
Offer a very short reply. 0.61. What is the ratio of the Net Disbursements (current US$) of Belarus in 2007 to that in 2012?
Your answer should be very brief. 0.14. What is the ratio of the Net Disbursements (current US$) in Other small states in 2007 to that in 2013?
Your answer should be compact. 2.46. What is the ratio of the Net Disbursements (current US$) in Sub-Saharan Africa (developing only) in 2007 to that in 2013?
Offer a very short reply. 7.15. What is the ratio of the Net Disbursements (current US$) in Upper middle income in 2007 to that in 2013?
Provide a short and direct response. 0.74. What is the ratio of the Net Disbursements (current US$) of Belarus in 2007 to that in 2013?
Make the answer very short. 0.22. What is the ratio of the Net Disbursements (current US$) of Other small states in 2008 to that in 2010?
Your response must be concise. 5.62. What is the ratio of the Net Disbursements (current US$) in Sub-Saharan Africa (developing only) in 2008 to that in 2010?
Your response must be concise. 12.67. What is the ratio of the Net Disbursements (current US$) in Upper middle income in 2008 to that in 2010?
Keep it short and to the point. 2.39. What is the ratio of the Net Disbursements (current US$) of Belarus in 2008 to that in 2010?
Offer a terse response. 1.25. What is the ratio of the Net Disbursements (current US$) in Other small states in 2008 to that in 2011?
Provide a succinct answer. 0.7. What is the ratio of the Net Disbursements (current US$) of Sub-Saharan Africa (developing only) in 2008 to that in 2011?
Provide a short and direct response. 11.38. What is the ratio of the Net Disbursements (current US$) of Upper middle income in 2008 to that in 2011?
Ensure brevity in your answer.  2.02. What is the ratio of the Net Disbursements (current US$) of Other small states in 2008 to that in 2012?
Provide a succinct answer. 1.1. What is the ratio of the Net Disbursements (current US$) in Sub-Saharan Africa (developing only) in 2008 to that in 2012?
Give a very brief answer. 9.93. What is the ratio of the Net Disbursements (current US$) in Upper middle income in 2008 to that in 2012?
Offer a very short reply. 1.68. What is the ratio of the Net Disbursements (current US$) in Belarus in 2008 to that in 2012?
Make the answer very short. 0.39. What is the ratio of the Net Disbursements (current US$) of Other small states in 2008 to that in 2013?
Make the answer very short. 1.73. What is the ratio of the Net Disbursements (current US$) of Sub-Saharan Africa (developing only) in 2008 to that in 2013?
Offer a terse response. 10.29. What is the ratio of the Net Disbursements (current US$) of Upper middle income in 2008 to that in 2013?
Give a very brief answer. 2.04. What is the ratio of the Net Disbursements (current US$) in Belarus in 2008 to that in 2013?
Provide a succinct answer. 0.62. What is the ratio of the Net Disbursements (current US$) of Sub-Saharan Africa (developing only) in 2010 to that in 2011?
Keep it short and to the point. 0.9. What is the ratio of the Net Disbursements (current US$) in Upper middle income in 2010 to that in 2011?
Offer a terse response. 0.84. What is the ratio of the Net Disbursements (current US$) of Belarus in 2010 to that in 2011?
Make the answer very short. 3.2. What is the ratio of the Net Disbursements (current US$) in Other small states in 2010 to that in 2012?
Your answer should be very brief. 0.2. What is the ratio of the Net Disbursements (current US$) of Sub-Saharan Africa (developing only) in 2010 to that in 2012?
Your response must be concise. 0.78. What is the ratio of the Net Disbursements (current US$) in Upper middle income in 2010 to that in 2012?
Give a very brief answer. 0.7. What is the ratio of the Net Disbursements (current US$) of Belarus in 2010 to that in 2012?
Provide a succinct answer. 0.31. What is the ratio of the Net Disbursements (current US$) of Other small states in 2010 to that in 2013?
Your response must be concise. 0.31. What is the ratio of the Net Disbursements (current US$) in Sub-Saharan Africa (developing only) in 2010 to that in 2013?
Provide a succinct answer. 0.81. What is the ratio of the Net Disbursements (current US$) of Upper middle income in 2010 to that in 2013?
Keep it short and to the point. 0.85. What is the ratio of the Net Disbursements (current US$) of Other small states in 2011 to that in 2012?
Provide a succinct answer. 1.56. What is the ratio of the Net Disbursements (current US$) in Sub-Saharan Africa (developing only) in 2011 to that in 2012?
Provide a short and direct response. 0.87. What is the ratio of the Net Disbursements (current US$) in Upper middle income in 2011 to that in 2012?
Keep it short and to the point. 0.83. What is the ratio of the Net Disbursements (current US$) of Belarus in 2011 to that in 2012?
Provide a succinct answer. 0.1. What is the ratio of the Net Disbursements (current US$) in Other small states in 2011 to that in 2013?
Keep it short and to the point. 2.46. What is the ratio of the Net Disbursements (current US$) in Sub-Saharan Africa (developing only) in 2011 to that in 2013?
Provide a short and direct response. 0.9. What is the ratio of the Net Disbursements (current US$) in Upper middle income in 2011 to that in 2013?
Offer a very short reply. 1.01. What is the ratio of the Net Disbursements (current US$) of Belarus in 2011 to that in 2013?
Provide a succinct answer. 0.16. What is the ratio of the Net Disbursements (current US$) of Other small states in 2012 to that in 2013?
Offer a very short reply. 1.58. What is the ratio of the Net Disbursements (current US$) in Sub-Saharan Africa (developing only) in 2012 to that in 2013?
Keep it short and to the point. 1.04. What is the ratio of the Net Disbursements (current US$) in Upper middle income in 2012 to that in 2013?
Make the answer very short. 1.21. What is the ratio of the Net Disbursements (current US$) of Belarus in 2012 to that in 2013?
Give a very brief answer. 1.59. What is the difference between the highest and the second highest Net Disbursements (current US$) in Other small states?
Keep it short and to the point. 0. What is the difference between the highest and the second highest Net Disbursements (current US$) in Sub-Saharan Africa (developing only)?
Provide a short and direct response. 7.59e+06. What is the difference between the highest and the second highest Net Disbursements (current US$) of Upper middle income?
Make the answer very short. 8.70e+05. What is the difference between the highest and the second highest Net Disbursements (current US$) in Belarus?
Provide a succinct answer. 1.90e+05. What is the difference between the highest and the lowest Net Disbursements (current US$) of Other small states?
Offer a very short reply. 6.30e+05. What is the difference between the highest and the lowest Net Disbursements (current US$) in Sub-Saharan Africa (developing only)?
Keep it short and to the point. 2.37e+07. What is the difference between the highest and the lowest Net Disbursements (current US$) of Upper middle income?
Give a very brief answer. 4.91e+06. What is the difference between the highest and the lowest Net Disbursements (current US$) in Belarus?
Offer a very short reply. 4.60e+05. 